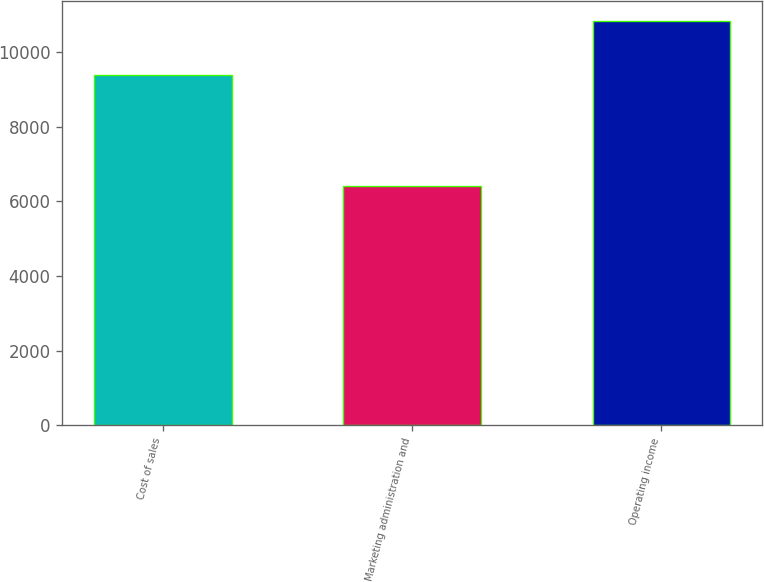Convert chart. <chart><loc_0><loc_0><loc_500><loc_500><bar_chart><fcel>Cost of sales<fcel>Marketing administration and<fcel>Operating income<nl><fcel>9391<fcel>6405<fcel>10815<nl></chart> 